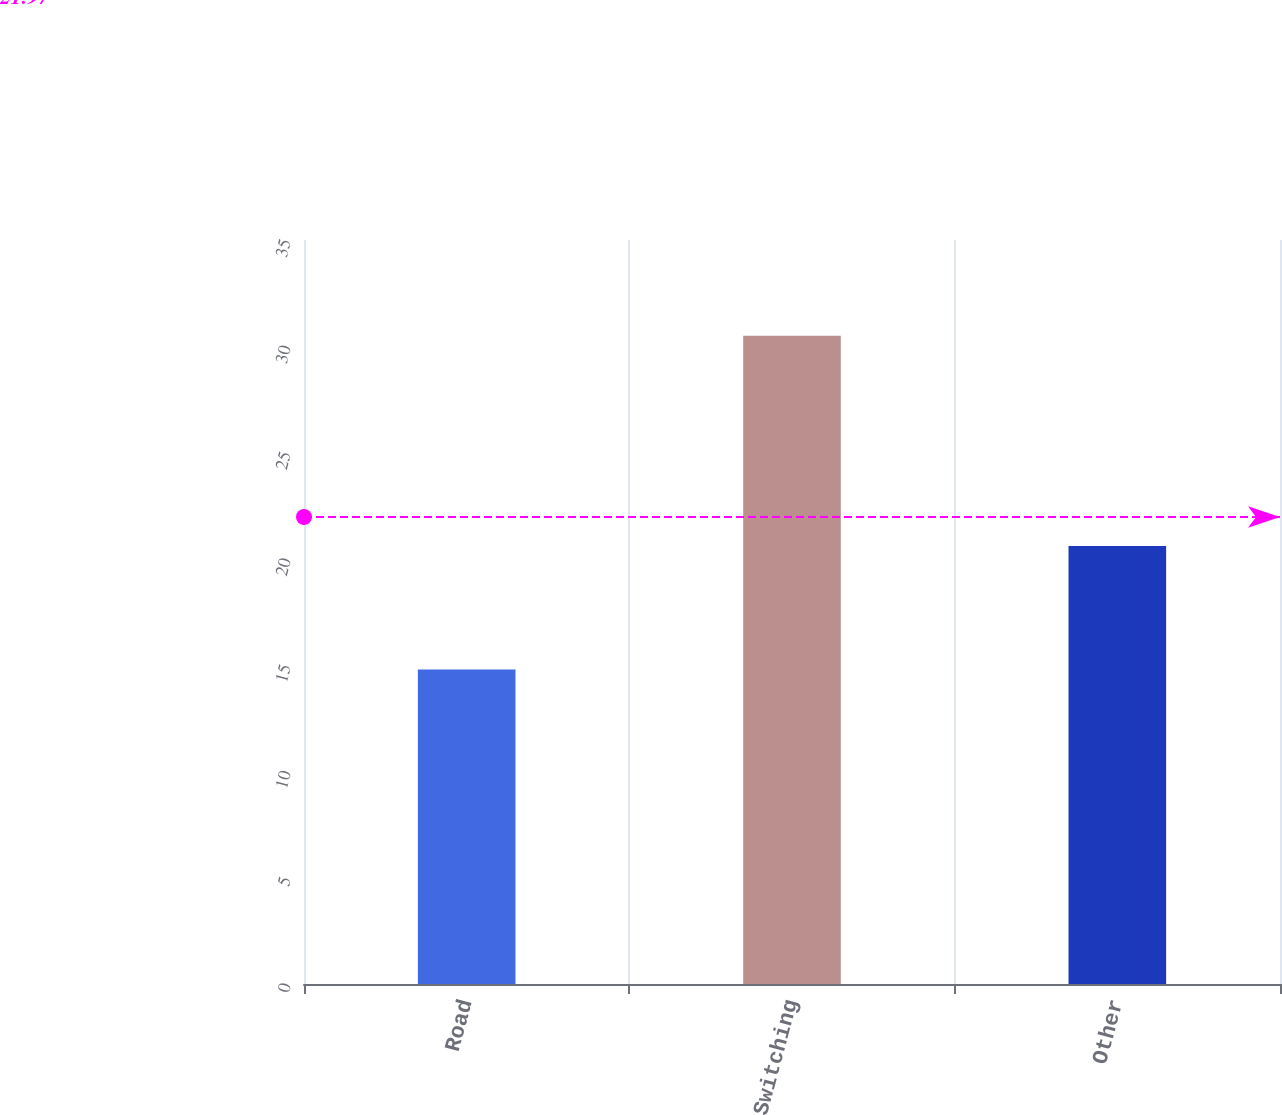<chart> <loc_0><loc_0><loc_500><loc_500><bar_chart><fcel>Road<fcel>Switching<fcel>Other<nl><fcel>14.8<fcel>30.5<fcel>20.6<nl></chart> 